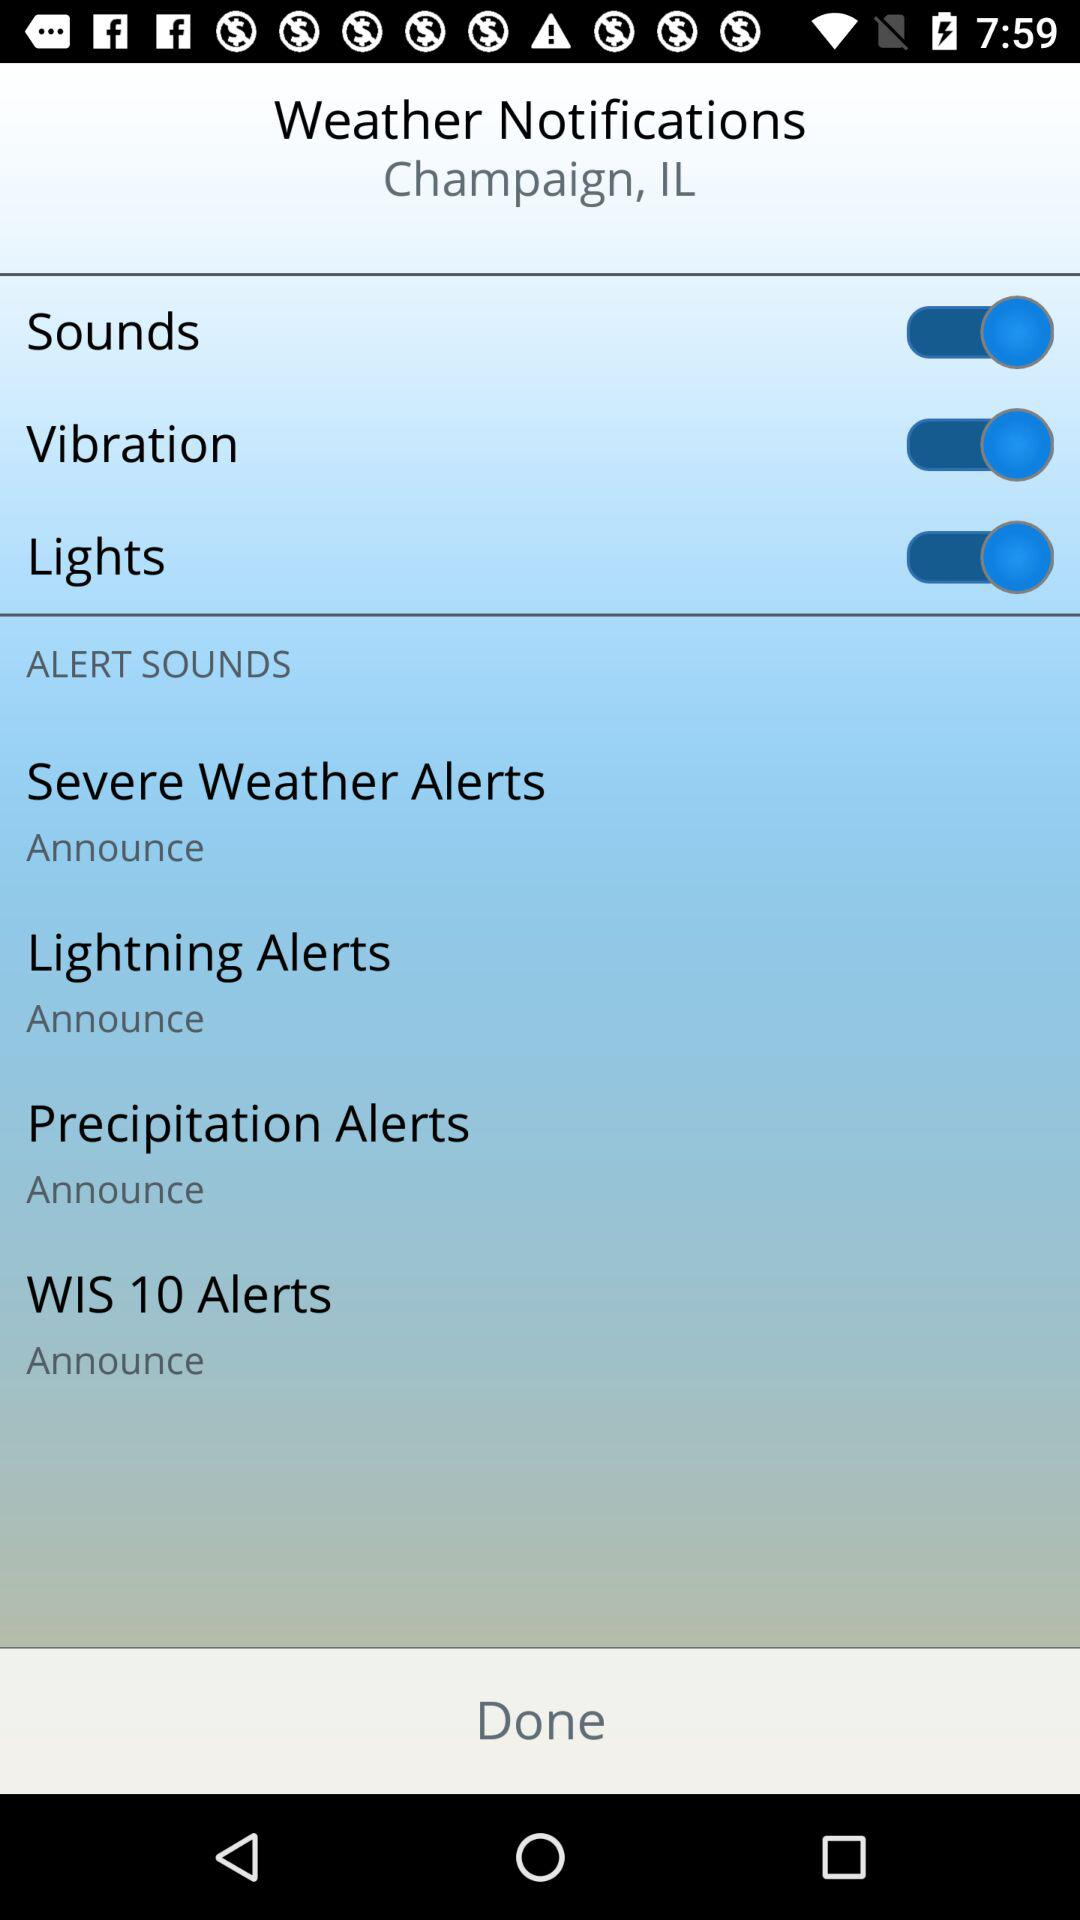How many alert sounds are available?
Answer the question using a single word or phrase. 4 